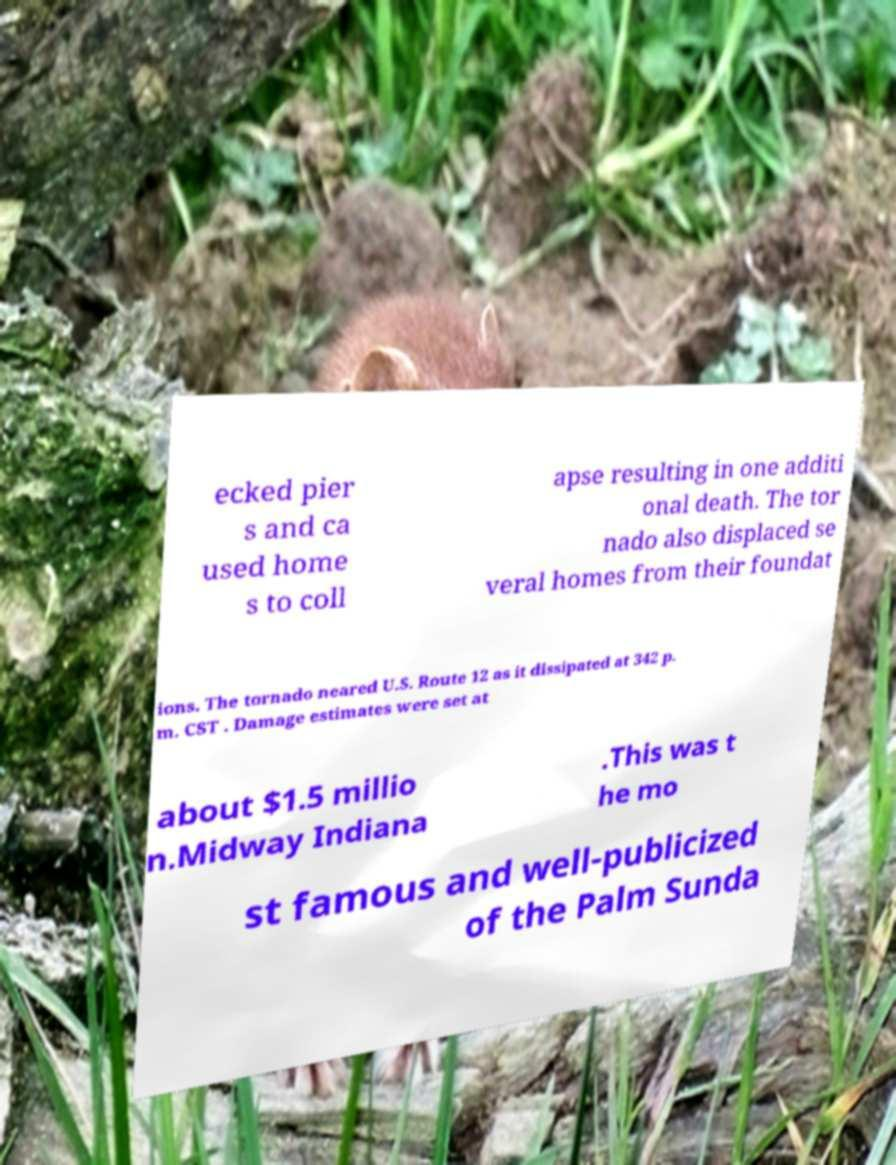I need the written content from this picture converted into text. Can you do that? ecked pier s and ca used home s to coll apse resulting in one additi onal death. The tor nado also displaced se veral homes from their foundat ions. The tornado neared U.S. Route 12 as it dissipated at 342 p. m. CST . Damage estimates were set at about $1.5 millio n.Midway Indiana .This was t he mo st famous and well-publicized of the Palm Sunda 